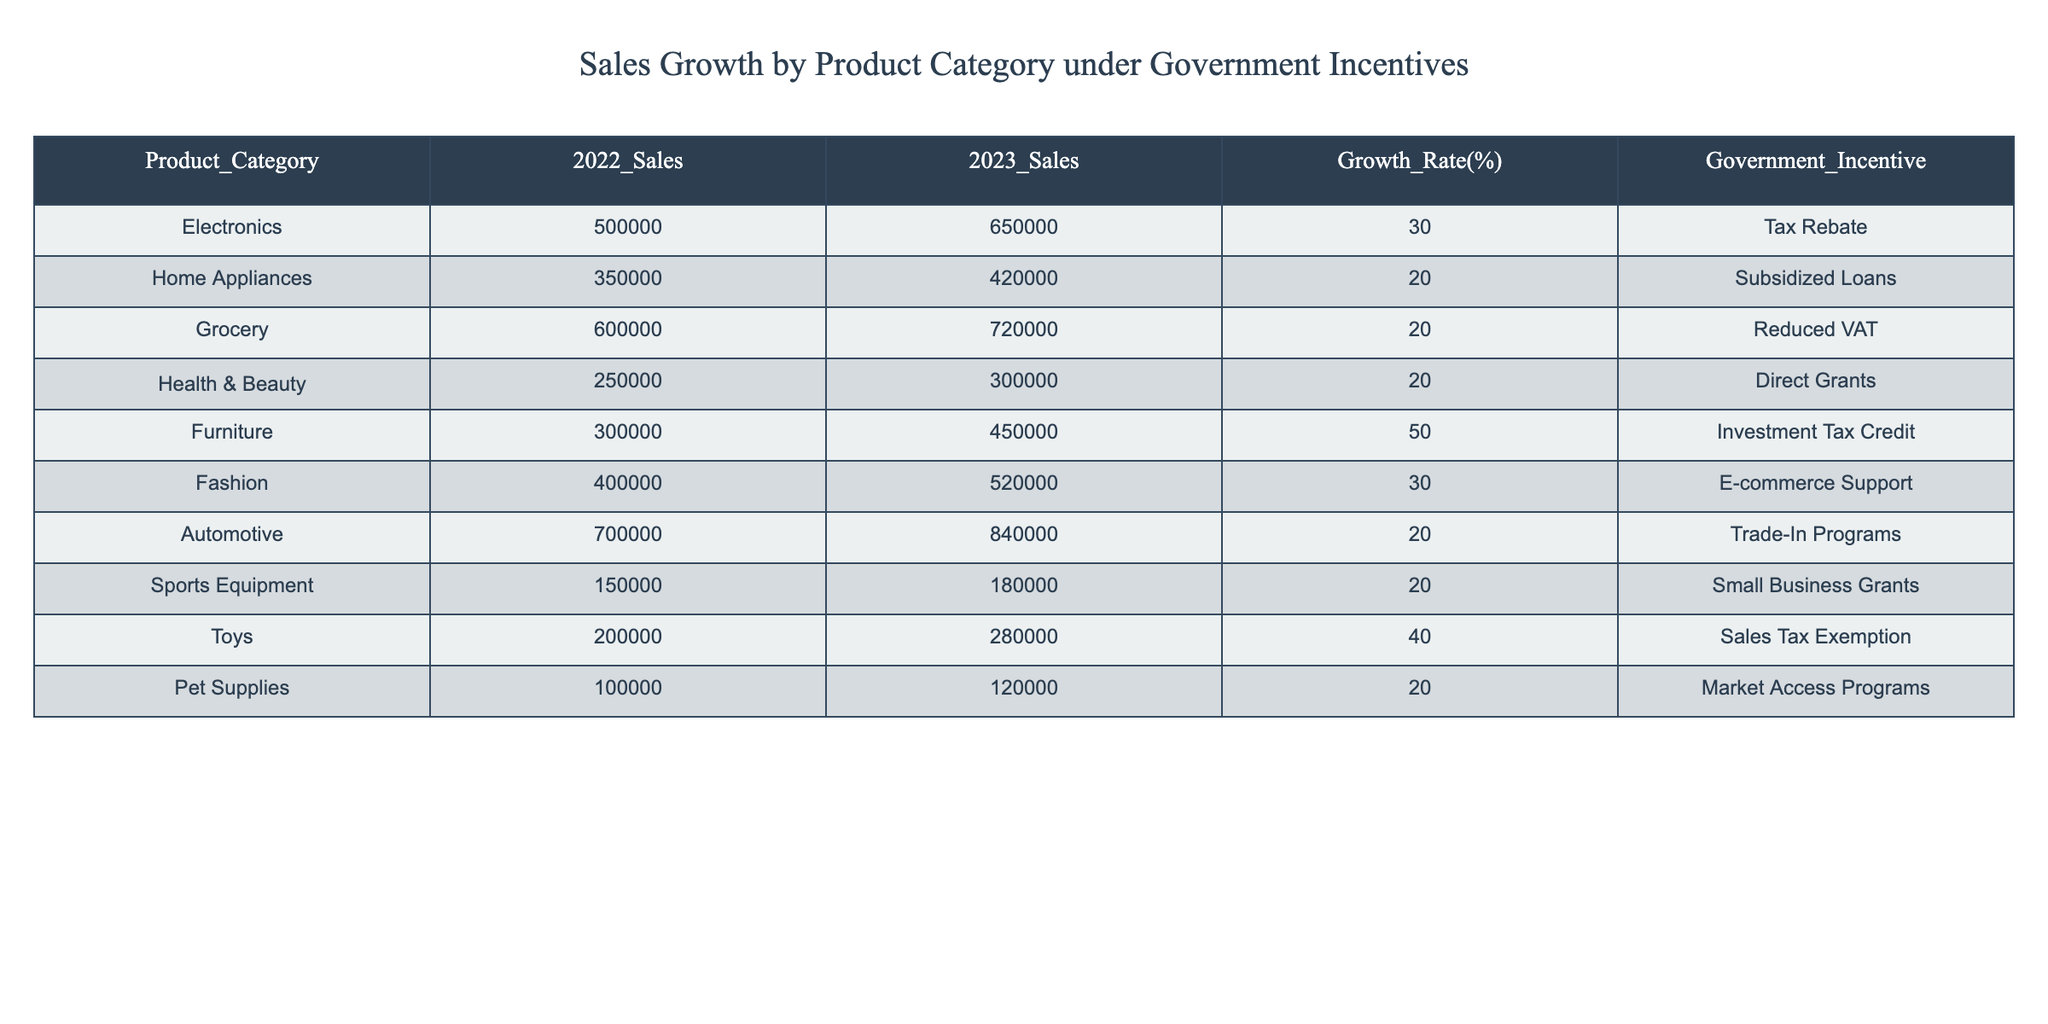What is the sales growth percentage for the Electronics category? The sales growth percentage for the Electronics category is listed directly in the table under the "Growth Rate(%)" column next to Electronics. It states 30%.
Answer: 30% Which product category experienced the highest sales growth in 2023? The table can be examined to find the maximum value in the "Growth Rate(%)" column. Looking through the values, the Furniture category shows the highest growth at 50%.
Answer: Furniture What was the total sales amount for the Grocery and Health & Beauty categories in 2023? To find the total sales for the Grocery and Health & Beauty categories, we add their 2023 sales amounts: Grocery (720000) + Health & Beauty (300000) = 1020000.
Answer: 1020000 Is the Automotive category's growth rate higher than that of the Home Appliances category? Looking at the "Growth Rate(%)" values, the Automotive category has a growth rate of 20%, while Home Appliances has a growth rate of 20% as well. Since they are equal, the answer is no.
Answer: No Which government incentive category corresponds with the highest sales growth? By reviewing the "Growth Rate(%)" in tandem with the "Government Incentive" column, we observe that the Furniture category, with a growth rate of 50%, corresponds to the "Investment Tax Credit" incentive.
Answer: Investment Tax Credit What is the difference in sales between the Fashion and Pet Supplies categories in 2023? We can calculate this by subtracting the 2023 sales of Pet Supplies from the 2023 sales of Fashion. Fashion's sales are 520000, and Pet Supplies' sales are 120000. Therefore, the difference is 520000 - 120000 = 400000.
Answer: 400000 Did any product categories see a sales growth rate of over 40%? Analyzing the "Growth Rate(%)" column, we see that the Furniture (50%) and Toys (40%) categories have values above 40%. Therefore, yes, there are categories that achieved this growth rate.
Answer: Yes What is the average sales growth rate across all categories? First, we add up all the growth rates: 30 + 20 + 20 + 20 + 50 + 30 + 20 + 20 + 40 + 20 = 270. Then, we divide by the number of product categories, which is 10. So the average growth rate is 270 / 10 = 27%.
Answer: 27% 